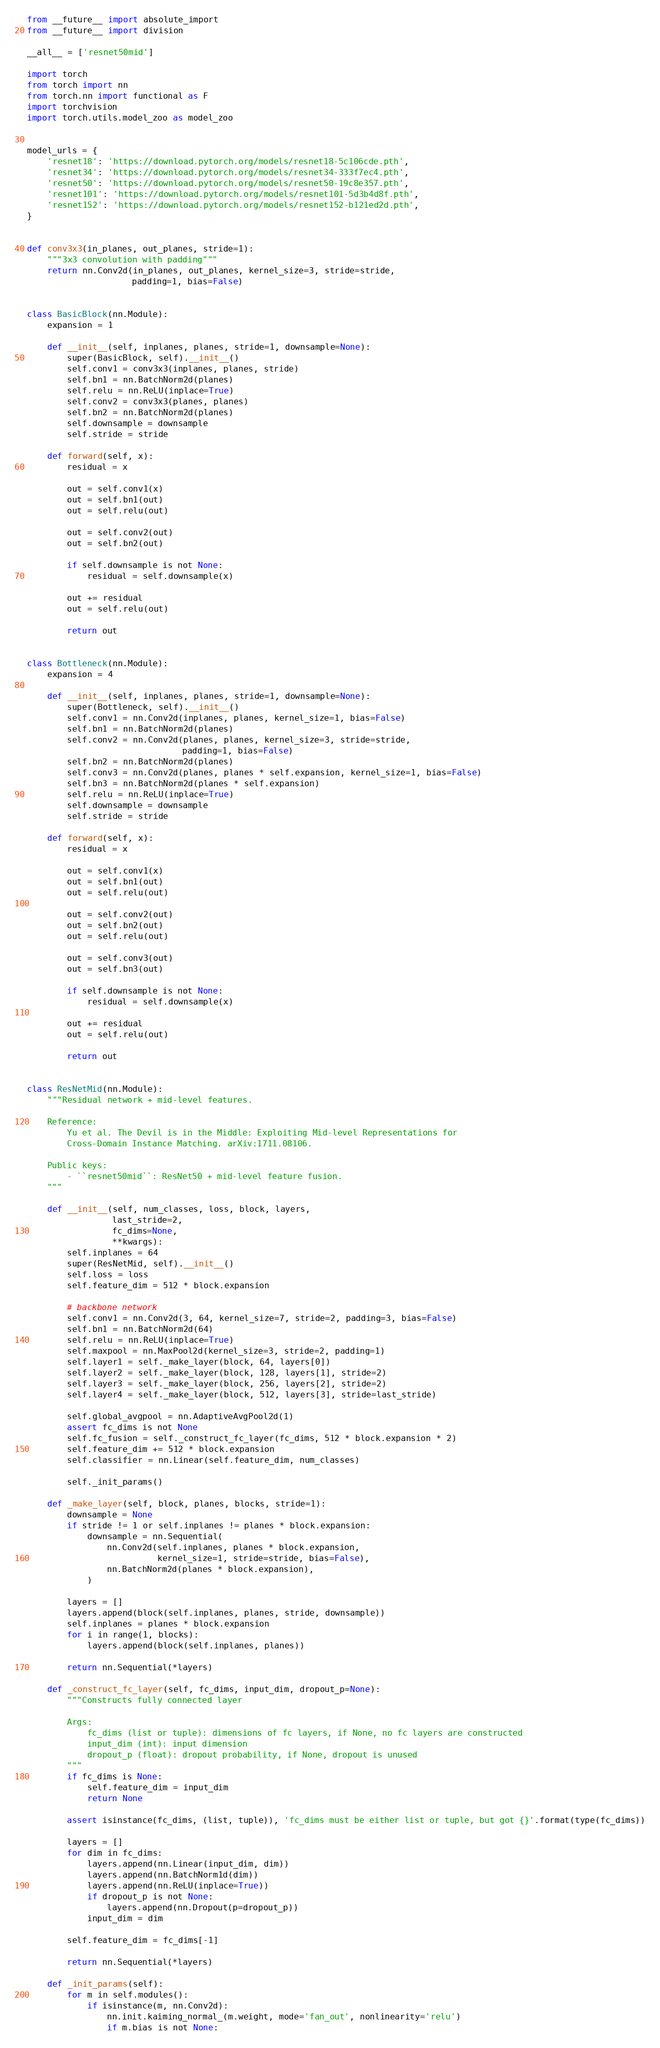Convert code to text. <code><loc_0><loc_0><loc_500><loc_500><_Python_>from __future__ import absolute_import
from __future__ import division

__all__ = ['resnet50mid']

import torch
from torch import nn
from torch.nn import functional as F
import torchvision
import torch.utils.model_zoo as model_zoo


model_urls = {
    'resnet18': 'https://download.pytorch.org/models/resnet18-5c106cde.pth',
    'resnet34': 'https://download.pytorch.org/models/resnet34-333f7ec4.pth',
    'resnet50': 'https://download.pytorch.org/models/resnet50-19c8e357.pth',
    'resnet101': 'https://download.pytorch.org/models/resnet101-5d3b4d8f.pth',
    'resnet152': 'https://download.pytorch.org/models/resnet152-b121ed2d.pth',
}


def conv3x3(in_planes, out_planes, stride=1):
    """3x3 convolution with padding"""
    return nn.Conv2d(in_planes, out_planes, kernel_size=3, stride=stride,
                     padding=1, bias=False)


class BasicBlock(nn.Module):
    expansion = 1

    def __init__(self, inplanes, planes, stride=1, downsample=None):
        super(BasicBlock, self).__init__()
        self.conv1 = conv3x3(inplanes, planes, stride)
        self.bn1 = nn.BatchNorm2d(planes)
        self.relu = nn.ReLU(inplace=True)
        self.conv2 = conv3x3(planes, planes)
        self.bn2 = nn.BatchNorm2d(planes)
        self.downsample = downsample
        self.stride = stride

    def forward(self, x):
        residual = x

        out = self.conv1(x)
        out = self.bn1(out)
        out = self.relu(out)

        out = self.conv2(out)
        out = self.bn2(out)

        if self.downsample is not None:
            residual = self.downsample(x)

        out += residual
        out = self.relu(out)

        return out


class Bottleneck(nn.Module):
    expansion = 4

    def __init__(self, inplanes, planes, stride=1, downsample=None):
        super(Bottleneck, self).__init__()
        self.conv1 = nn.Conv2d(inplanes, planes, kernel_size=1, bias=False)
        self.bn1 = nn.BatchNorm2d(planes)
        self.conv2 = nn.Conv2d(planes, planes, kernel_size=3, stride=stride,
                               padding=1, bias=False)
        self.bn2 = nn.BatchNorm2d(planes)
        self.conv3 = nn.Conv2d(planes, planes * self.expansion, kernel_size=1, bias=False)
        self.bn3 = nn.BatchNorm2d(planes * self.expansion)
        self.relu = nn.ReLU(inplace=True)
        self.downsample = downsample
        self.stride = stride

    def forward(self, x):
        residual = x

        out = self.conv1(x)
        out = self.bn1(out)
        out = self.relu(out)

        out = self.conv2(out)
        out = self.bn2(out)
        out = self.relu(out)

        out = self.conv3(out)
        out = self.bn3(out)

        if self.downsample is not None:
            residual = self.downsample(x)

        out += residual
        out = self.relu(out)

        return out


class ResNetMid(nn.Module):
    """Residual network + mid-level features.
    
    Reference:
        Yu et al. The Devil is in the Middle: Exploiting Mid-level Representations for
        Cross-Domain Instance Matching. arXiv:1711.08106.

    Public keys:
        - ``resnet50mid``: ResNet50 + mid-level feature fusion.
    """
    
    def __init__(self, num_classes, loss, block, layers,
                 last_stride=2,
                 fc_dims=None,
                 **kwargs):
        self.inplanes = 64
        super(ResNetMid, self).__init__()
        self.loss = loss
        self.feature_dim = 512 * block.expansion
        
        # backbone network
        self.conv1 = nn.Conv2d(3, 64, kernel_size=7, stride=2, padding=3, bias=False)
        self.bn1 = nn.BatchNorm2d(64)
        self.relu = nn.ReLU(inplace=True)
        self.maxpool = nn.MaxPool2d(kernel_size=3, stride=2, padding=1)
        self.layer1 = self._make_layer(block, 64, layers[0])
        self.layer2 = self._make_layer(block, 128, layers[1], stride=2)
        self.layer3 = self._make_layer(block, 256, layers[2], stride=2)
        self.layer4 = self._make_layer(block, 512, layers[3], stride=last_stride)
        
        self.global_avgpool = nn.AdaptiveAvgPool2d(1)
        assert fc_dims is not None
        self.fc_fusion = self._construct_fc_layer(fc_dims, 512 * block.expansion * 2)
        self.feature_dim += 512 * block.expansion
        self.classifier = nn.Linear(self.feature_dim, num_classes)

        self._init_params()

    def _make_layer(self, block, planes, blocks, stride=1):
        downsample = None
        if stride != 1 or self.inplanes != planes * block.expansion:
            downsample = nn.Sequential(
                nn.Conv2d(self.inplanes, planes * block.expansion,
                          kernel_size=1, stride=stride, bias=False),
                nn.BatchNorm2d(planes * block.expansion),
            )

        layers = []
        layers.append(block(self.inplanes, planes, stride, downsample))
        self.inplanes = planes * block.expansion
        for i in range(1, blocks):
            layers.append(block(self.inplanes, planes))

        return nn.Sequential(*layers)

    def _construct_fc_layer(self, fc_dims, input_dim, dropout_p=None):
        """Constructs fully connected layer

        Args:
            fc_dims (list or tuple): dimensions of fc layers, if None, no fc layers are constructed
            input_dim (int): input dimension
            dropout_p (float): dropout probability, if None, dropout is unused
        """
        if fc_dims is None:
            self.feature_dim = input_dim
            return None
        
        assert isinstance(fc_dims, (list, tuple)), 'fc_dims must be either list or tuple, but got {}'.format(type(fc_dims))
        
        layers = []
        for dim in fc_dims:
            layers.append(nn.Linear(input_dim, dim))
            layers.append(nn.BatchNorm1d(dim))
            layers.append(nn.ReLU(inplace=True))
            if dropout_p is not None:
                layers.append(nn.Dropout(p=dropout_p))
            input_dim = dim
        
        self.feature_dim = fc_dims[-1]
        
        return nn.Sequential(*layers)

    def _init_params(self):
        for m in self.modules():
            if isinstance(m, nn.Conv2d):
                nn.init.kaiming_normal_(m.weight, mode='fan_out', nonlinearity='relu')
                if m.bias is not None:</code> 